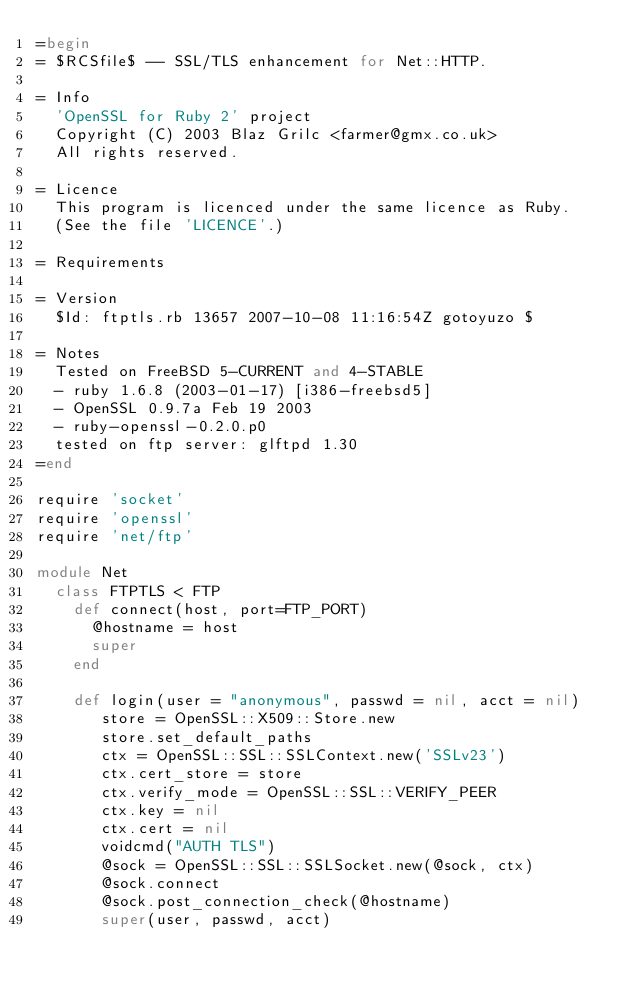Convert code to text. <code><loc_0><loc_0><loc_500><loc_500><_Ruby_>=begin
= $RCSfile$ -- SSL/TLS enhancement for Net::HTTP.

= Info
  'OpenSSL for Ruby 2' project
  Copyright (C) 2003 Blaz Grilc <farmer@gmx.co.uk>
  All rights reserved.

= Licence
  This program is licenced under the same licence as Ruby.
  (See the file 'LICENCE'.)

= Requirements

= Version
  $Id: ftptls.rb 13657 2007-10-08 11:16:54Z gotoyuzo $
  
= Notes
  Tested on FreeBSD 5-CURRENT and 4-STABLE
  - ruby 1.6.8 (2003-01-17) [i386-freebsd5]
  - OpenSSL 0.9.7a Feb 19 2003
  - ruby-openssl-0.2.0.p0
  tested on ftp server: glftpd 1.30
=end

require 'socket'
require 'openssl'
require 'net/ftp'

module Net
  class FTPTLS < FTP
    def connect(host, port=FTP_PORT)
      @hostname = host
      super
    end

    def login(user = "anonymous", passwd = nil, acct = nil)
       store = OpenSSL::X509::Store.new
       store.set_default_paths
       ctx = OpenSSL::SSL::SSLContext.new('SSLv23')
       ctx.cert_store = store
       ctx.verify_mode = OpenSSL::SSL::VERIFY_PEER
       ctx.key = nil
       ctx.cert = nil
       voidcmd("AUTH TLS")
       @sock = OpenSSL::SSL::SSLSocket.new(@sock, ctx)
       @sock.connect
       @sock.post_connection_check(@hostname)
       super(user, passwd, acct)</code> 